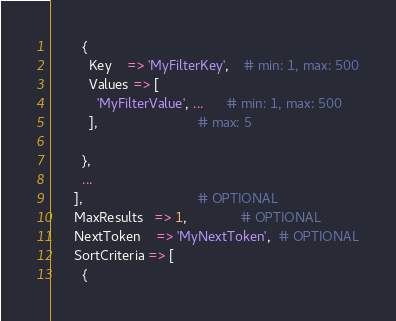Convert code to text. <code><loc_0><loc_0><loc_500><loc_500><_Perl_>        {
          Key    => 'MyFilterKey',    # min: 1, max: 500
          Values => [
            'MyFilterValue', ...      # min: 1, max: 500
          ],                          # max: 5

        },
        ...
      ],                              # OPTIONAL
      MaxResults   => 1,              # OPTIONAL
      NextToken    => 'MyNextToken',  # OPTIONAL
      SortCriteria => [
        {</code> 